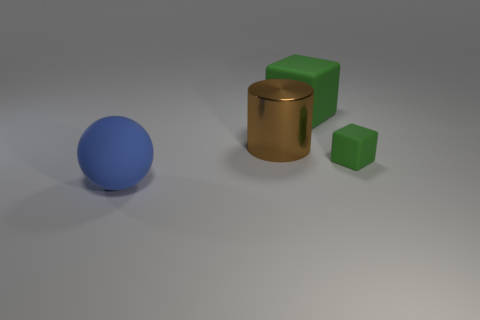The thing that is both in front of the metal cylinder and right of the big matte sphere is made of what material?
Your answer should be very brief. Rubber. What number of big things are either brown objects or blue cubes?
Your answer should be very brief. 1. The blue rubber ball is what size?
Offer a very short reply. Large. There is a blue thing; what shape is it?
Keep it short and to the point. Sphere. Is there any other thing that has the same shape as the brown thing?
Your answer should be very brief. No. Is the number of cubes that are on the right side of the small object less than the number of blue cylinders?
Provide a short and direct response. No. Do the block behind the large brown metallic thing and the tiny object have the same color?
Provide a short and direct response. Yes. How many matte objects are either yellow things or large brown cylinders?
Your answer should be very brief. 0. What color is the tiny thing that is the same material as the sphere?
Make the answer very short. Green. How many balls are either small rubber objects or big metal things?
Your answer should be compact. 0. 